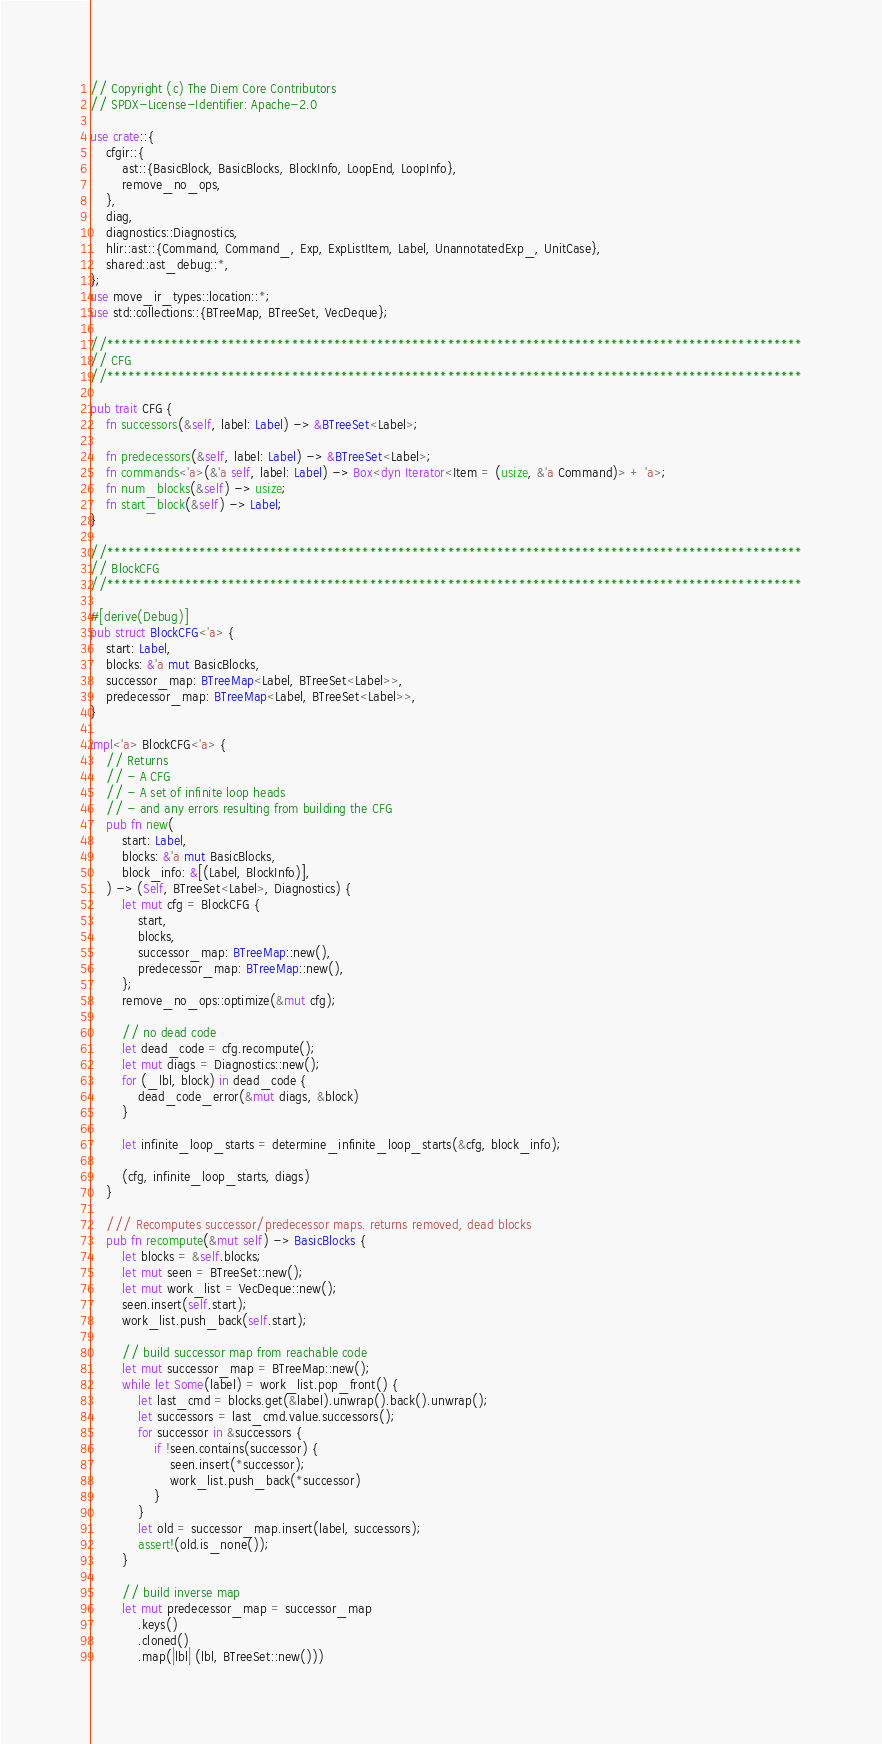Convert code to text. <code><loc_0><loc_0><loc_500><loc_500><_Rust_>// Copyright (c) The Diem Core Contributors
// SPDX-License-Identifier: Apache-2.0

use crate::{
    cfgir::{
        ast::{BasicBlock, BasicBlocks, BlockInfo, LoopEnd, LoopInfo},
        remove_no_ops,
    },
    diag,
    diagnostics::Diagnostics,
    hlir::ast::{Command, Command_, Exp, ExpListItem, Label, UnannotatedExp_, UnitCase},
    shared::ast_debug::*,
};
use move_ir_types::location::*;
use std::collections::{BTreeMap, BTreeSet, VecDeque};

//**************************************************************************************************
// CFG
//**************************************************************************************************

pub trait CFG {
    fn successors(&self, label: Label) -> &BTreeSet<Label>;

    fn predecessors(&self, label: Label) -> &BTreeSet<Label>;
    fn commands<'a>(&'a self, label: Label) -> Box<dyn Iterator<Item = (usize, &'a Command)> + 'a>;
    fn num_blocks(&self) -> usize;
    fn start_block(&self) -> Label;
}

//**************************************************************************************************
// BlockCFG
//**************************************************************************************************

#[derive(Debug)]
pub struct BlockCFG<'a> {
    start: Label,
    blocks: &'a mut BasicBlocks,
    successor_map: BTreeMap<Label, BTreeSet<Label>>,
    predecessor_map: BTreeMap<Label, BTreeSet<Label>>,
}

impl<'a> BlockCFG<'a> {
    // Returns
    // - A CFG
    // - A set of infinite loop heads
    // - and any errors resulting from building the CFG
    pub fn new(
        start: Label,
        blocks: &'a mut BasicBlocks,
        block_info: &[(Label, BlockInfo)],
    ) -> (Self, BTreeSet<Label>, Diagnostics) {
        let mut cfg = BlockCFG {
            start,
            blocks,
            successor_map: BTreeMap::new(),
            predecessor_map: BTreeMap::new(),
        };
        remove_no_ops::optimize(&mut cfg);

        // no dead code
        let dead_code = cfg.recompute();
        let mut diags = Diagnostics::new();
        for (_lbl, block) in dead_code {
            dead_code_error(&mut diags, &block)
        }

        let infinite_loop_starts = determine_infinite_loop_starts(&cfg, block_info);

        (cfg, infinite_loop_starts, diags)
    }

    /// Recomputes successor/predecessor maps. returns removed, dead blocks
    pub fn recompute(&mut self) -> BasicBlocks {
        let blocks = &self.blocks;
        let mut seen = BTreeSet::new();
        let mut work_list = VecDeque::new();
        seen.insert(self.start);
        work_list.push_back(self.start);

        // build successor map from reachable code
        let mut successor_map = BTreeMap::new();
        while let Some(label) = work_list.pop_front() {
            let last_cmd = blocks.get(&label).unwrap().back().unwrap();
            let successors = last_cmd.value.successors();
            for successor in &successors {
                if !seen.contains(successor) {
                    seen.insert(*successor);
                    work_list.push_back(*successor)
                }
            }
            let old = successor_map.insert(label, successors);
            assert!(old.is_none());
        }

        // build inverse map
        let mut predecessor_map = successor_map
            .keys()
            .cloned()
            .map(|lbl| (lbl, BTreeSet::new()))</code> 